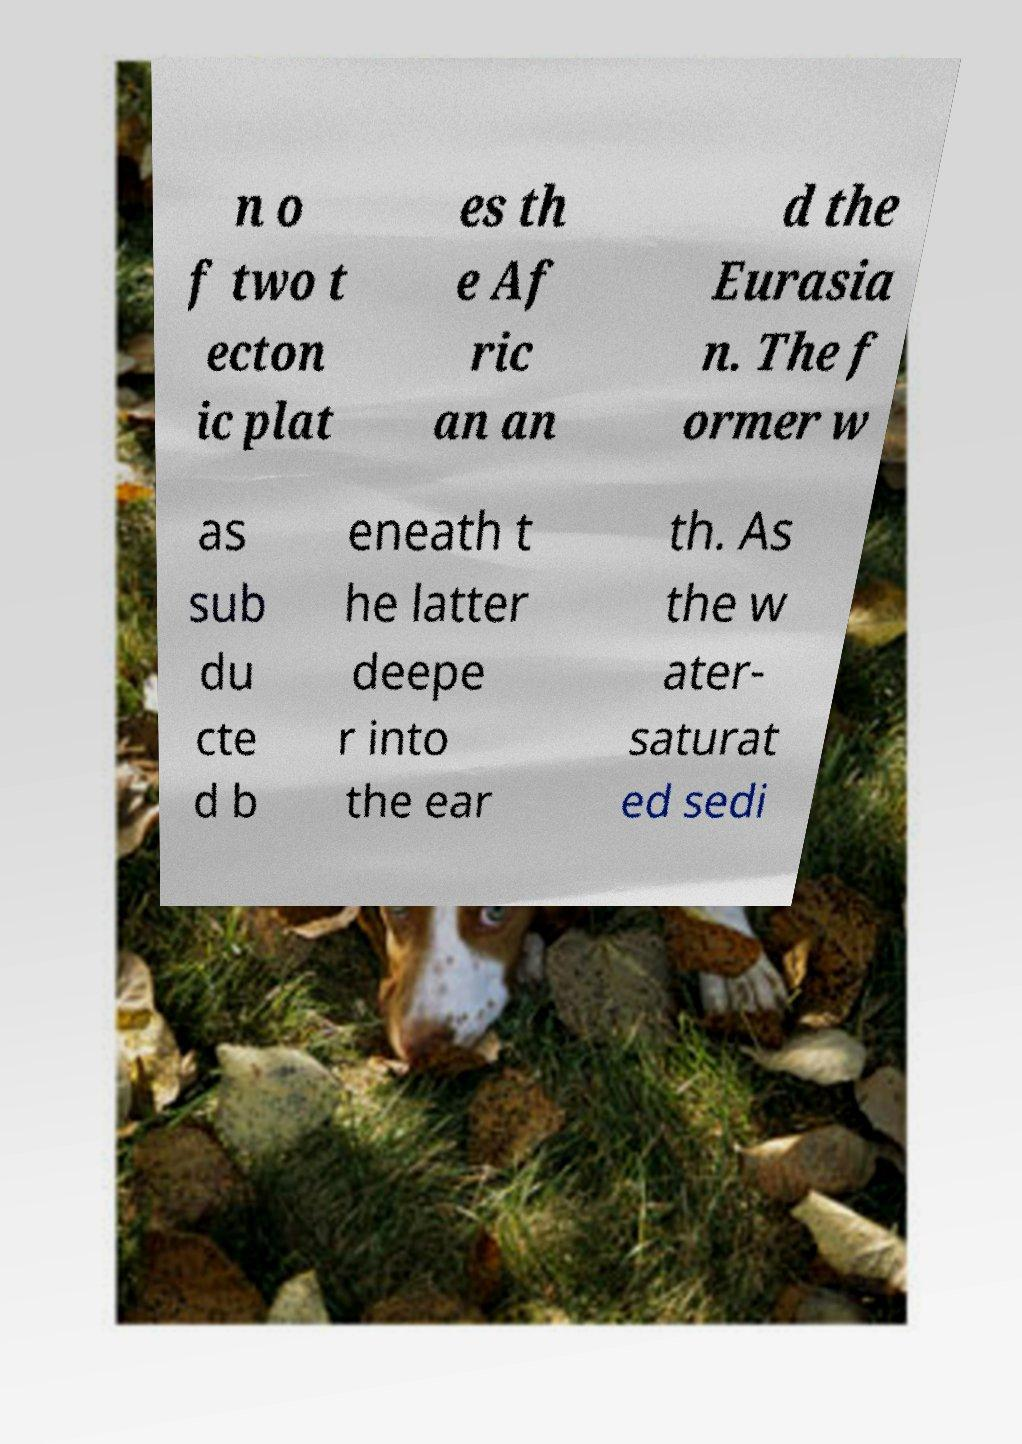I need the written content from this picture converted into text. Can you do that? n o f two t ecton ic plat es th e Af ric an an d the Eurasia n. The f ormer w as sub du cte d b eneath t he latter deepe r into the ear th. As the w ater- saturat ed sedi 